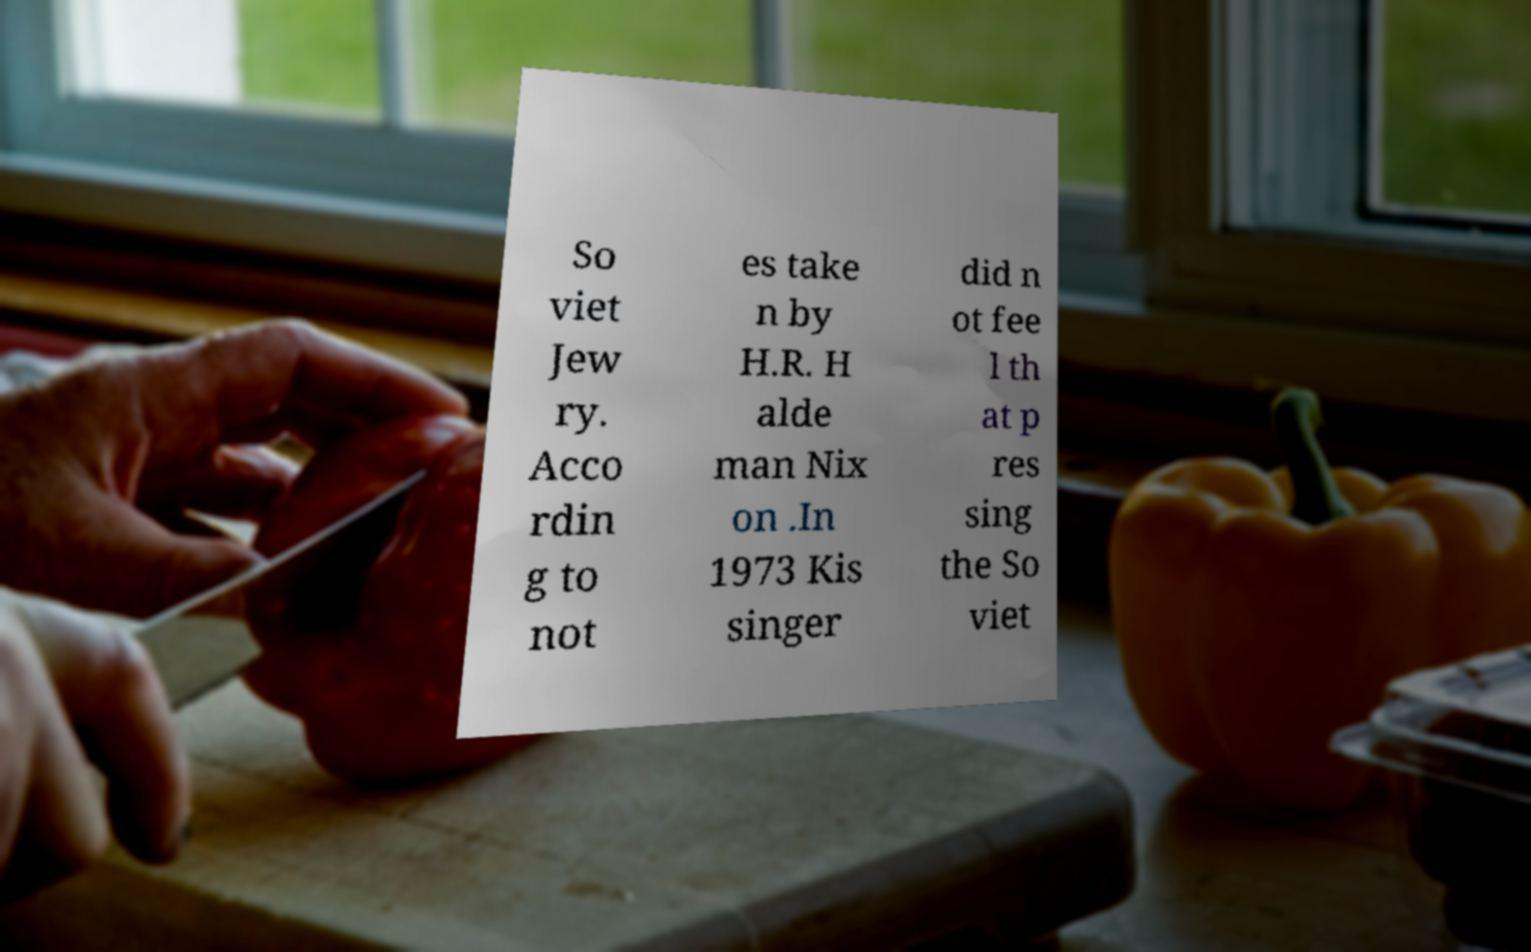Can you read and provide the text displayed in the image?This photo seems to have some interesting text. Can you extract and type it out for me? So viet Jew ry. Acco rdin g to not es take n by H.R. H alde man Nix on .In 1973 Kis singer did n ot fee l th at p res sing the So viet 